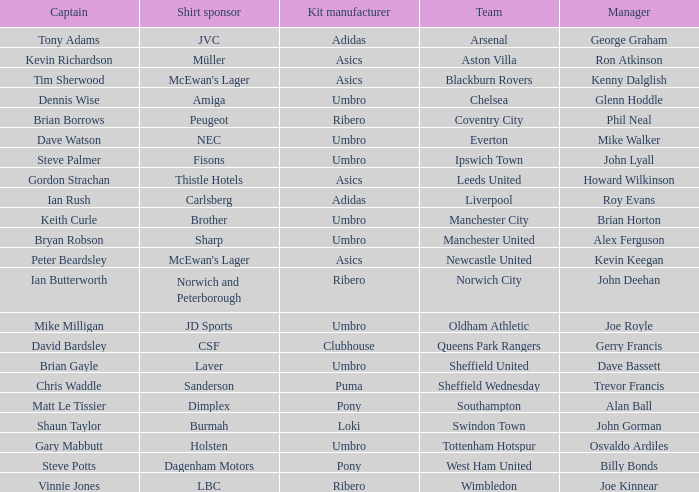Which manager has Manchester City as the team? Brian Horton. 